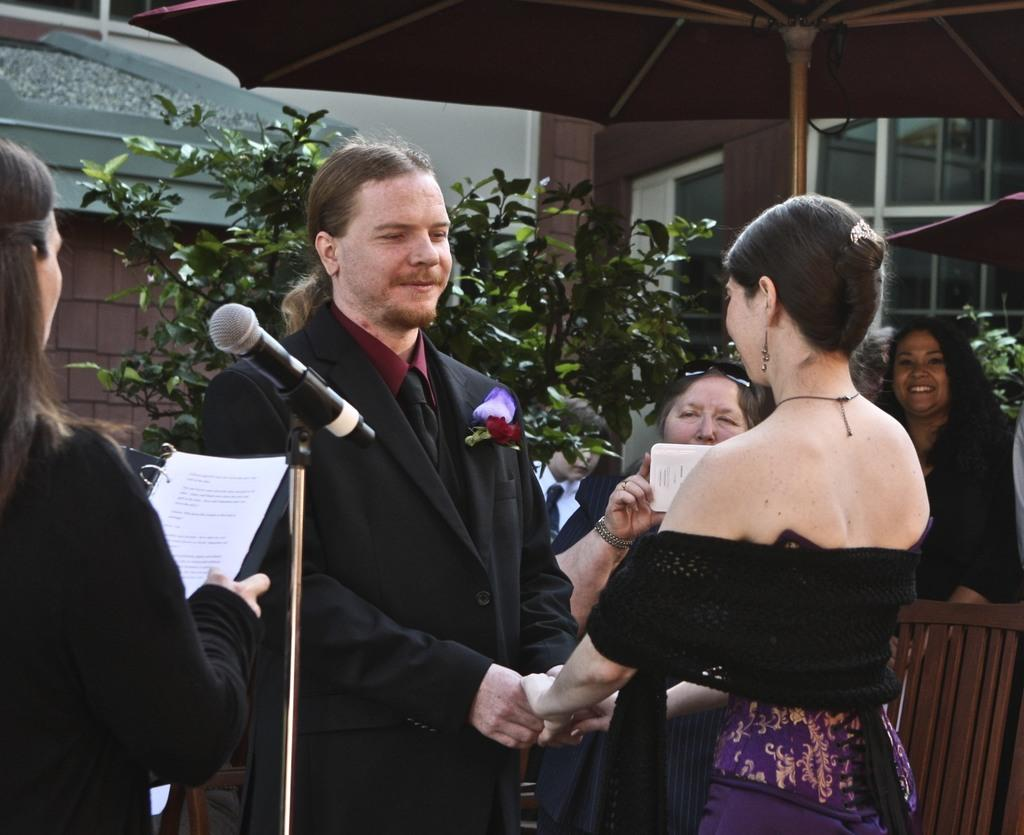How many people are in the image? There are people in the image, but the exact number is not specified. What else can be seen in the image besides people? There are plants, an umbrella, a microphone (mike), and a building in the background of the image. What is the person on the left side of the image holding? The person on the left side of the image is holding a file. Can you describe the setting of the image? The image appears to be set outdoors, as there are plants and an umbrella present, and there is a building in the background. How many worms can be seen crawling on the microphone in the image? There are no worms present in the image, so it is not possible to determine how many would be crawling on the microphone. 